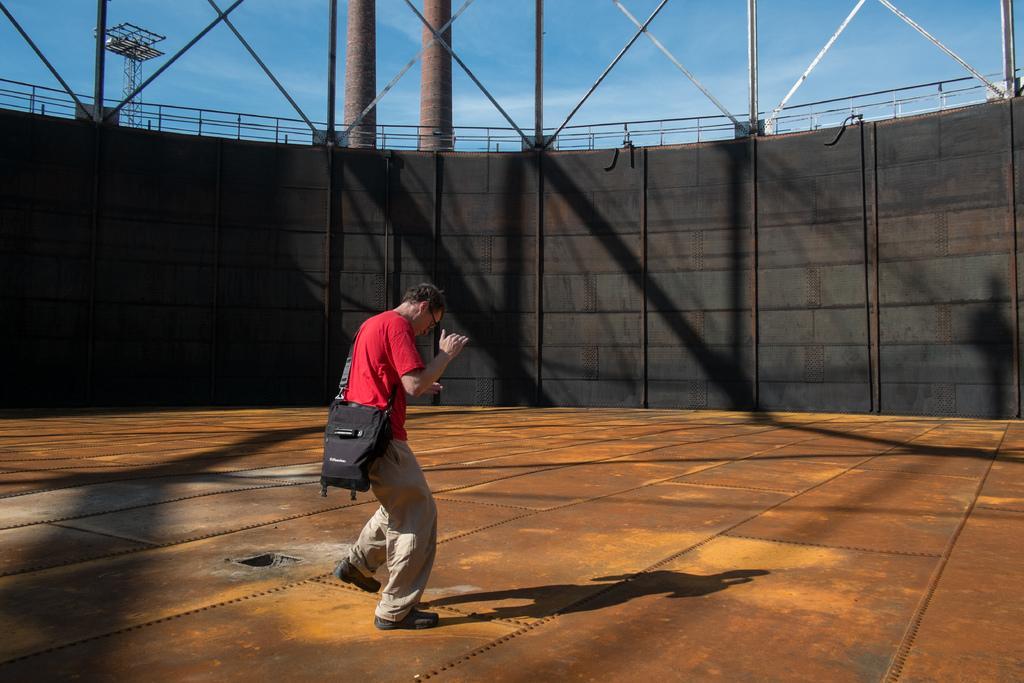Describe this image in one or two sentences. In this image we can see men standing on the floor and wearing a bag across his body. In the background there are walls, grills, tower and sky with clouds. 